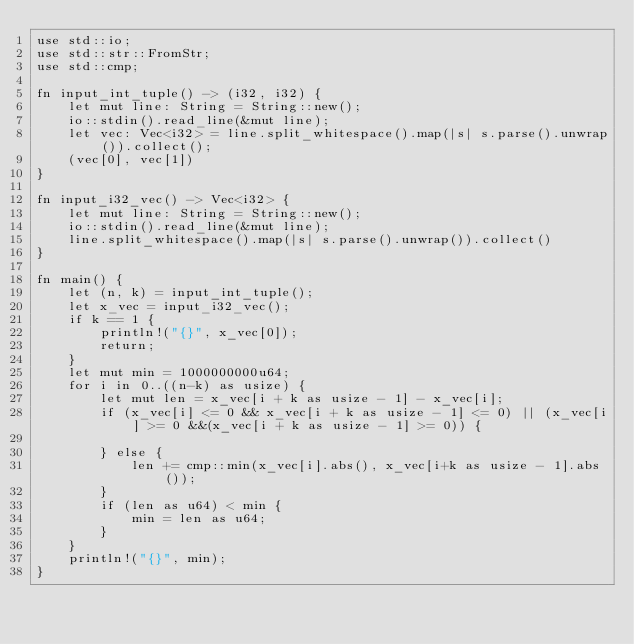<code> <loc_0><loc_0><loc_500><loc_500><_Rust_>use std::io;
use std::str::FromStr;
use std::cmp;

fn input_int_tuple() -> (i32, i32) {
    let mut line: String = String::new();
    io::stdin().read_line(&mut line);
    let vec: Vec<i32> = line.split_whitespace().map(|s| s.parse().unwrap()).collect();
    (vec[0], vec[1])
}

fn input_i32_vec() -> Vec<i32> {
    let mut line: String = String::new();
    io::stdin().read_line(&mut line);
    line.split_whitespace().map(|s| s.parse().unwrap()).collect()
}

fn main() {
    let (n, k) = input_int_tuple();
    let x_vec = input_i32_vec();
    if k == 1 {
        println!("{}", x_vec[0]);
        return;
    }
    let mut min = 1000000000u64;
    for i in 0..((n-k) as usize) {
        let mut len = x_vec[i + k as usize - 1] - x_vec[i];
        if (x_vec[i] <= 0 && x_vec[i + k as usize - 1] <= 0) || (x_vec[i] >= 0 &&(x_vec[i + k as usize - 1] >= 0)) {
            
        } else {
            len += cmp::min(x_vec[i].abs(), x_vec[i+k as usize - 1].abs());
        }
        if (len as u64) < min {
            min = len as u64;
        }
    }
    println!("{}", min);
}
</code> 